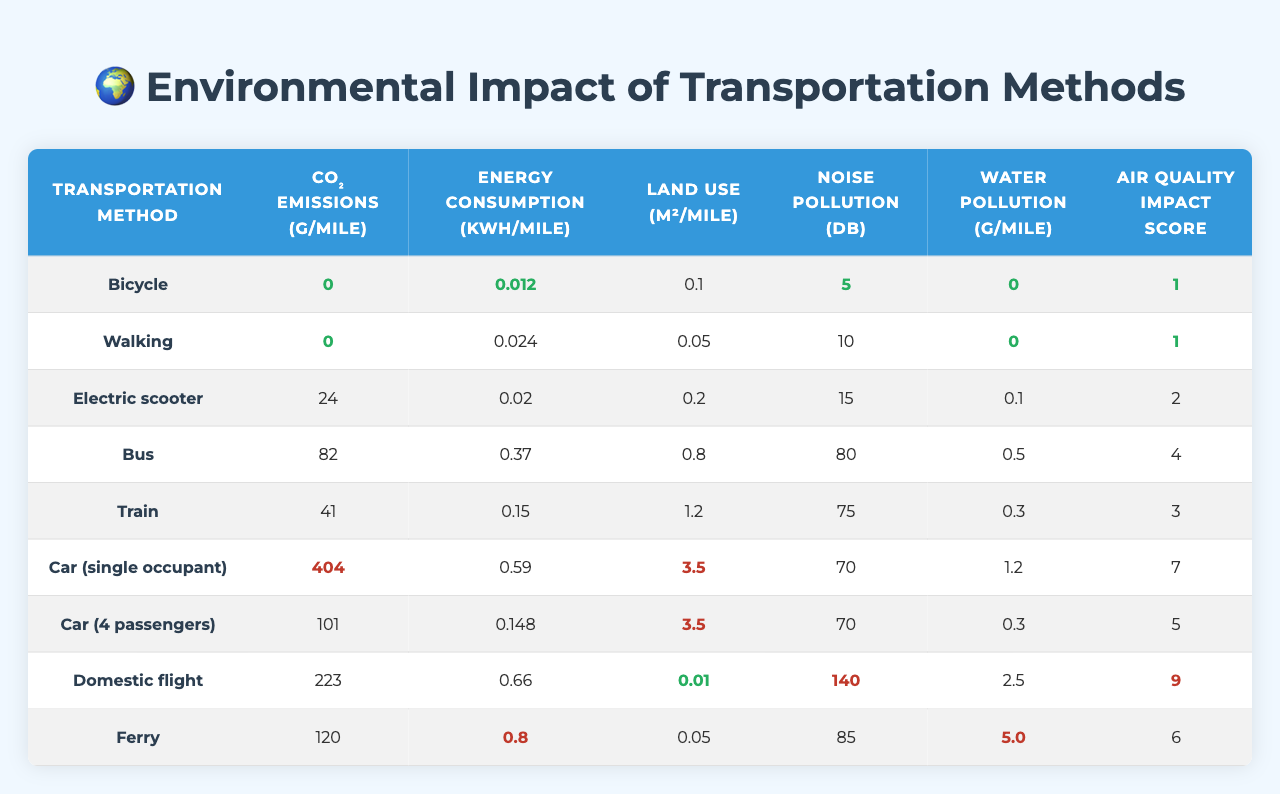What are the CO₂ emissions for a Bus? The table lists the CO₂ emissions for the Bus as 82 grams per mile.
Answer: 82 grams Which transportation method has the highest noise pollution? The highest noise pollution recorded in the table is for Domestic flight, with 140 decibels.
Answer: Domestic flight What is the average energy consumption for Bicycle and Walking? The energy consumption for Bicycle is 0.012 kWh/mile and for Walking is 0.024 kWh/mile. The average is (0.012 + 0.024) / 2 = 0.018 kWh/mile.
Answer: 0.018 kWh/mile Is the water pollution for a Car (single occupant) greater than for a Bus? The water pollution for Car (single occupant) is 1.2 grams per mile, while for Bus it is 0.5 grams per mile; thus, 1.2 is greater than 0.5.
Answer: Yes What is the total land use for Car (4 passengers) and Domestic flight combined? The land use for Car (4 passengers) is 3.5 square meters per mile and for Domestic flight is 0.01 square meters per mile. The total is 3.5 + 0.01 = 3.51 square meters per mile.
Answer: 3.51 square meters Which transportation method has the best air quality impact score? The table shows that Bicycle and Walking both have an air quality impact score of 1, which is the lowest score.
Answer: Bicycle and Walking How much less energy is consumed by an Electric scooter compared to a Domestic flight? The energy consumption for an Electric scooter is 0.020 kWh/mile and for Domestic flight is 0.660 kWh/mile. The difference is 0.660 - 0.020 = 0.640 kWh/mile.
Answer: 0.640 kWh/mile Is the CO₂ emission of a Train lower than that of a Ferry? The CO₂ emissions for Train are 41 grams per mile and for Ferry are 120 grams per mile; thus, 41 is lower than 120.
Answer: Yes What is the average air quality impact score for Cars? The air quality score for Car (single occupant) is 7 and for Car (4 passengers) is 5. The average is (7 + 5) / 2 = 6.
Answer: 6 How do the CO₂ emissions of Bicycles and Electric scooters compare? Bicycles have CO₂ emissions of 0 grams per mile, whereas Electric scooters have 24 grams per mile; thus, Bicycles have lower emissions than Electric scooters.
Answer: Bicycles have lower emissions 